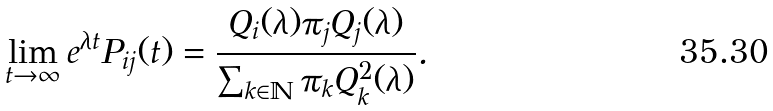<formula> <loc_0><loc_0><loc_500><loc_500>\lim _ { t \rightarrow \infty } e ^ { \lambda t } P _ { i j } ( t ) = \frac { Q _ { i } ( \lambda ) \pi _ { j } Q _ { j } ( \lambda ) } { \sum _ { k \in \mathbb { N } } \pi _ { k } Q _ { k } ^ { 2 } ( \lambda ) } .</formula> 